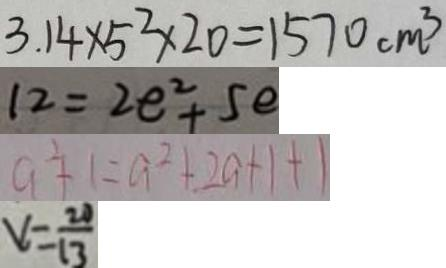Convert formula to latex. <formula><loc_0><loc_0><loc_500><loc_500>3 . 1 4 \times 5 ^ { 2 } \times 2 0 = 1 5 7 0 c m ^ { 3 } 
 1 2 = 2 e ^ { 2 } + 5 e 
 a ^ { 2 } + 1 = a ^ { 2 } + 2 a + 1 + 1 
 v = \frac { 2 0 } { 1 3 }</formula> 